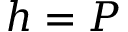Convert formula to latex. <formula><loc_0><loc_0><loc_500><loc_500>h = P</formula> 